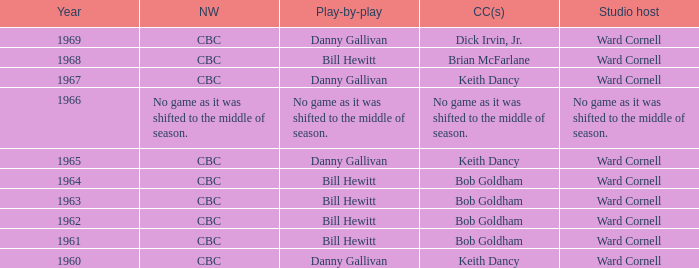Who gave the play by play commentary with studio host Ward Cornell? Danny Gallivan, Bill Hewitt, Danny Gallivan, Danny Gallivan, Bill Hewitt, Bill Hewitt, Bill Hewitt, Bill Hewitt, Danny Gallivan. 